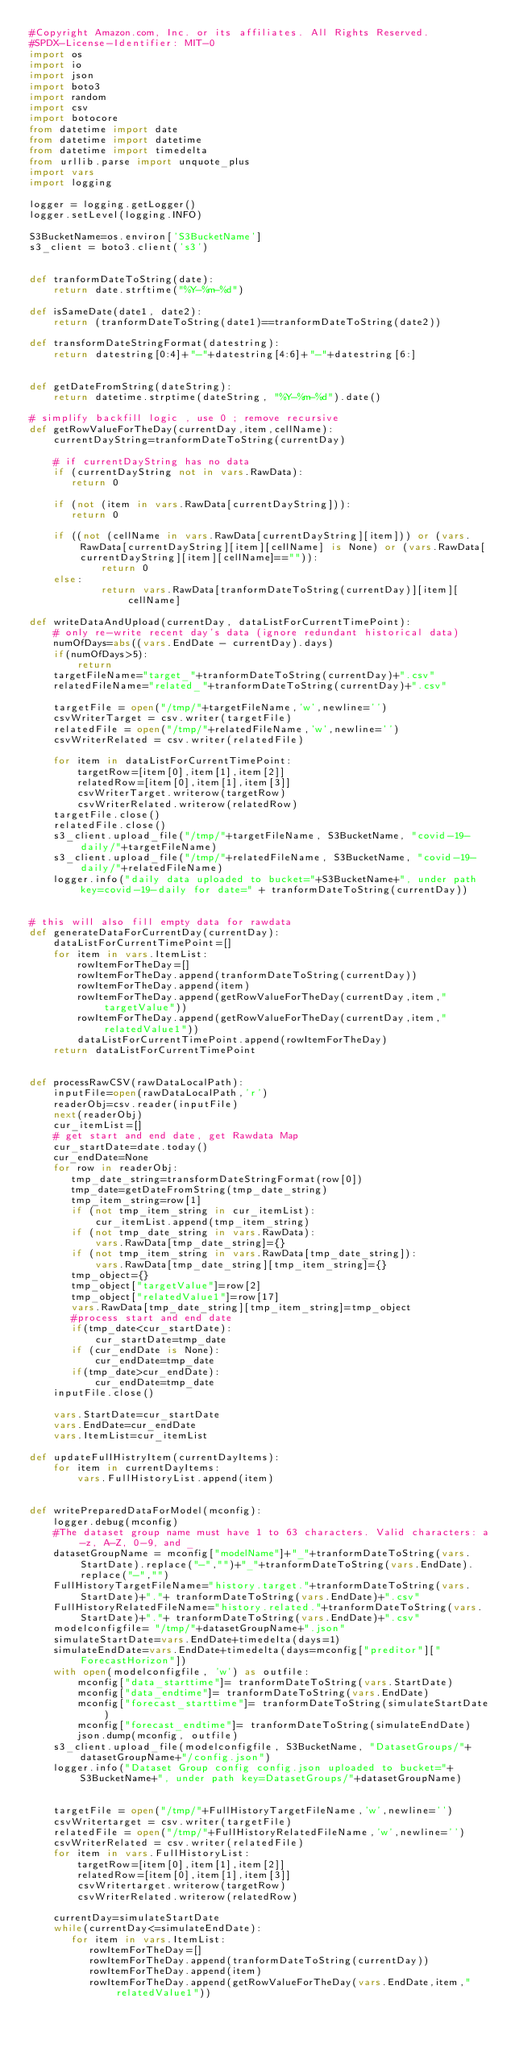Convert code to text. <code><loc_0><loc_0><loc_500><loc_500><_Python_>#Copyright Amazon.com, Inc. or its affiliates. All Rights Reserved.
#SPDX-License-Identifier: MIT-0
import os
import io
import json
import boto3
import random
import csv
import botocore
from datetime import date
from datetime import datetime
from datetime import timedelta
from urllib.parse import unquote_plus
import vars
import logging

logger = logging.getLogger()
logger.setLevel(logging.INFO)

S3BucketName=os.environ['S3BucketName']
s3_client = boto3.client('s3')


def tranformDateToString(date):
    return date.strftime("%Y-%m-%d")

def isSameDate(date1, date2):
    return (tranformDateToString(date1)==tranformDateToString(date2))

def transformDateStringFormat(datestring):
    return datestring[0:4]+"-"+datestring[4:6]+"-"+datestring[6:]


def getDateFromString(dateString):
    return datetime.strptime(dateString, "%Y-%m-%d").date()

# simplify backfill logic , use 0 ; remove recursive
def getRowValueForTheDay(currentDay,item,cellName):
    currentDayString=tranformDateToString(currentDay)

    # if currentDayString has no data
    if (currentDayString not in vars.RawData):
       return 0

    if (not (item in vars.RawData[currentDayString])):
       return 0

    if ((not (cellName in vars.RawData[currentDayString][item])) or (vars.RawData[currentDayString][item][cellName] is None) or (vars.RawData[currentDayString][item][cellName]=="")):
            return 0
    else:
            return vars.RawData[tranformDateToString(currentDay)][item][cellName]

def writeDataAndUpload(currentDay, dataListForCurrentTimePoint):
    # only re-write recent day's data (ignore redundant historical data)
    numOfDays=abs((vars.EndDate - currentDay).days)
    if(numOfDays>5):
        return
    targetFileName="target_"+tranformDateToString(currentDay)+".csv"
    relatedFileName="related_"+tranformDateToString(currentDay)+".csv"

    targetFile = open("/tmp/"+targetFileName,'w',newline='')
    csvWriterTarget = csv.writer(targetFile)
    relatedFile = open("/tmp/"+relatedFileName,'w',newline='')
    csvWriterRelated = csv.writer(relatedFile)

    for item in dataListForCurrentTimePoint:
        targetRow=[item[0],item[1],item[2]]
        relatedRow=[item[0],item[1],item[3]]
        csvWriterTarget.writerow(targetRow)
        csvWriterRelated.writerow(relatedRow)
    targetFile.close()
    relatedFile.close()
    s3_client.upload_file("/tmp/"+targetFileName, S3BucketName, "covid-19-daily/"+targetFileName)
    s3_client.upload_file("/tmp/"+relatedFileName, S3BucketName, "covid-19-daily/"+relatedFileName)
    logger.info("daily data uploaded to bucket="+S3BucketName+", under path key=covid-19-daily for date=" + tranformDateToString(currentDay))


# this will also fill empty data for rawdata
def generateDataForCurrentDay(currentDay):
    dataListForCurrentTimePoint=[]
    for item in vars.ItemList:
        rowItemForTheDay=[]
        rowItemForTheDay.append(tranformDateToString(currentDay))
        rowItemForTheDay.append(item)
        rowItemForTheDay.append(getRowValueForTheDay(currentDay,item,"targetValue"))
        rowItemForTheDay.append(getRowValueForTheDay(currentDay,item,"relatedValue1"))
        dataListForCurrentTimePoint.append(rowItemForTheDay)
    return dataListForCurrentTimePoint


def processRawCSV(rawDataLocalPath):
    inputFile=open(rawDataLocalPath,'r')
    readerObj=csv.reader(inputFile)
    next(readerObj)
    cur_itemList=[]
    # get start and end date, get Rawdata Map
    cur_startDate=date.today()
    cur_endDate=None
    for row in readerObj:
       tmp_date_string=transformDateStringFormat(row[0])
       tmp_date=getDateFromString(tmp_date_string)
       tmp_item_string=row[1]
       if (not tmp_item_string in cur_itemList):
           cur_itemList.append(tmp_item_string)
       if (not tmp_date_string in vars.RawData):
           vars.RawData[tmp_date_string]={}
       if (not tmp_item_string in vars.RawData[tmp_date_string]):
           vars.RawData[tmp_date_string][tmp_item_string]={}
       tmp_object={}
       tmp_object["targetValue"]=row[2]
       tmp_object["relatedValue1"]=row[17]
       vars.RawData[tmp_date_string][tmp_item_string]=tmp_object
       #process start and end date
       if(tmp_date<cur_startDate):
           cur_startDate=tmp_date
       if (cur_endDate is None):
           cur_endDate=tmp_date
       if(tmp_date>cur_endDate):
           cur_endDate=tmp_date
    inputFile.close()

    vars.StartDate=cur_startDate
    vars.EndDate=cur_endDate
    vars.ItemList=cur_itemList

def updateFullHistryItem(currentDayItems):
    for item in currentDayItems:
        vars.FullHistoryList.append(item)


def writePreparedDataForModel(mconfig):
    logger.debug(mconfig)
    #The dataset group name must have 1 to 63 characters. Valid characters: a-z, A-Z, 0-9, and _
    datasetGroupName = mconfig["modelName"]+"_"+tranformDateToString(vars.StartDate).replace("-","")+"_"+tranformDateToString(vars.EndDate).replace("-","")
    FullHistoryTargetFileName="history.target."+tranformDateToString(vars.StartDate)+"."+ tranformDateToString(vars.EndDate)+".csv"
    FullHistoryRelatedFileName="history.related."+tranformDateToString(vars.StartDate)+"."+ tranformDateToString(vars.EndDate)+".csv"
    modelconfigfile= "/tmp/"+datasetGroupName+".json"
    simulateStartDate=vars.EndDate+timedelta(days=1)
    simulateEndDate=vars.EndDate+timedelta(days=mconfig["preditor"]["ForecastHorizon"])
    with open(modelconfigfile, 'w') as outfile:
        mconfig["data_starttime"]= tranformDateToString(vars.StartDate)
        mconfig["data_endtime"]= tranformDateToString(vars.EndDate)
        mconfig["forecast_starttime"]= tranformDateToString(simulateStartDate)
        mconfig["forecast_endtime"]= tranformDateToString(simulateEndDate)
        json.dump(mconfig, outfile)
    s3_client.upload_file(modelconfigfile, S3BucketName, "DatasetGroups/"+datasetGroupName+"/config.json")
    logger.info("Dataset Group config config.json uploaded to bucket="+S3BucketName+", under path key=DatasetGroups/"+datasetGroupName)


    targetFile = open("/tmp/"+FullHistoryTargetFileName,'w',newline='')
    csvWritertarget = csv.writer(targetFile)
    relatedFile = open("/tmp/"+FullHistoryRelatedFileName,'w',newline='')
    csvWriterRelated = csv.writer(relatedFile)
    for item in vars.FullHistoryList:
        targetRow=[item[0],item[1],item[2]]
        relatedRow=[item[0],item[1],item[3]]
        csvWritertarget.writerow(targetRow)
        csvWriterRelated.writerow(relatedRow)

    currentDay=simulateStartDate
    while(currentDay<=simulateEndDate):
       for item in vars.ItemList:
          rowItemForTheDay=[]
          rowItemForTheDay.append(tranformDateToString(currentDay))
          rowItemForTheDay.append(item)
          rowItemForTheDay.append(getRowValueForTheDay(vars.EndDate,item,"relatedValue1"))</code> 